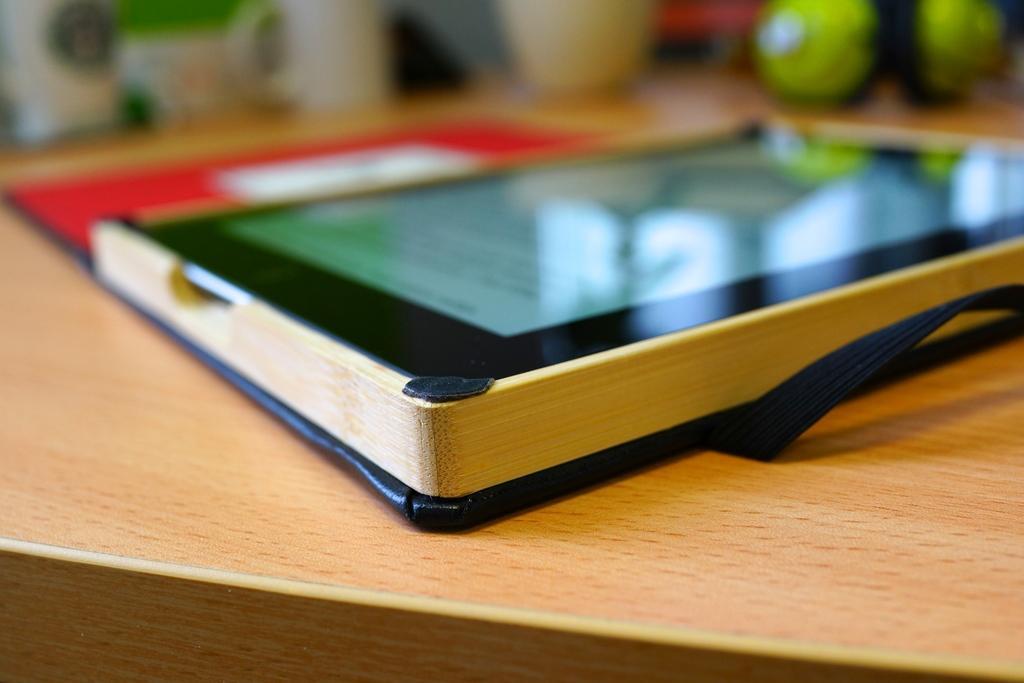Please provide a concise description of this image. In this picture, we see a tablet and a file in red color are placed on the table. In the right top of the picture, we see two balls in green color. In the background, it is blurred. 